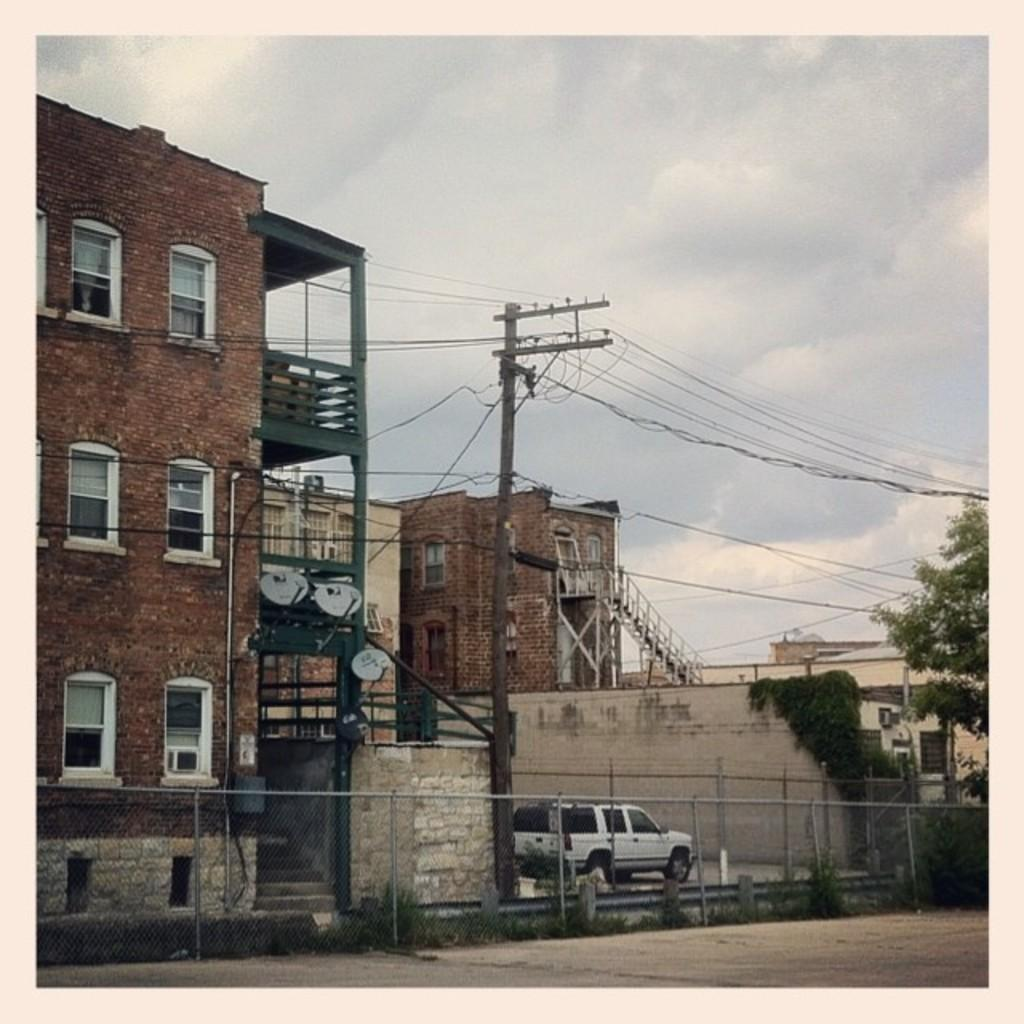What type of structures can be seen in the image? There are buildings in the image. What other natural elements are present in the image? There are trees in the image. What type of vehicle is visible in the image? There is a mini truck in the image. Are there any vertical structures in the image? Yes, there is a pole in the image. Are there any architectural features that allow for vertical movement? Yes, there are stairs in the image. How would you describe the weather based on the image? The sky is cloudy in the image. What type of blood vessels can be seen in the image? There are no blood vessels present in the image. What is the hammer used for in the image? There is no hammer present in the image. 